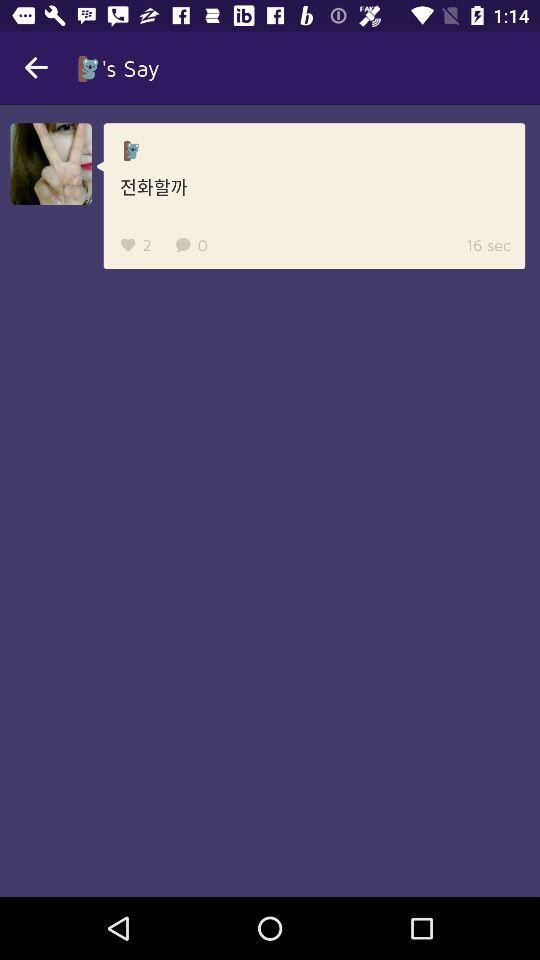How many more hearts are there than chats?
Answer the question using a single word or phrase. 2 